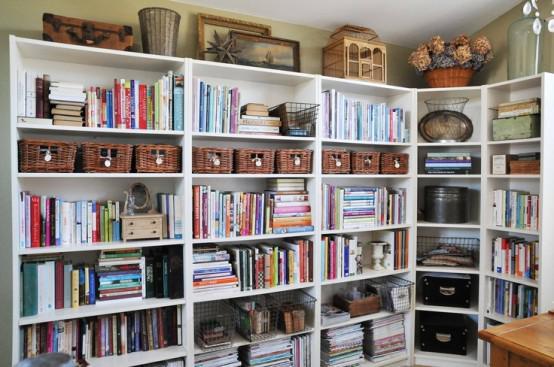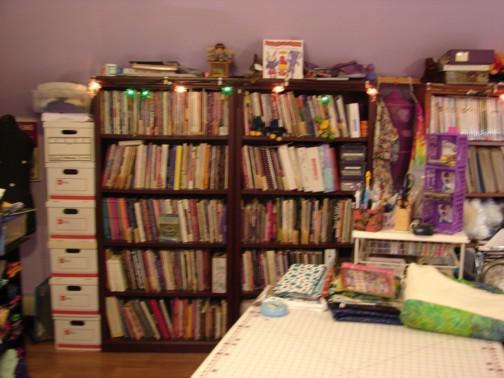The first image is the image on the left, the second image is the image on the right. Assess this claim about the two images: "The bookshelves in at least one image angle around the corner of room, so that they  extend outward on two walls.". Correct or not? Answer yes or no. Yes. 